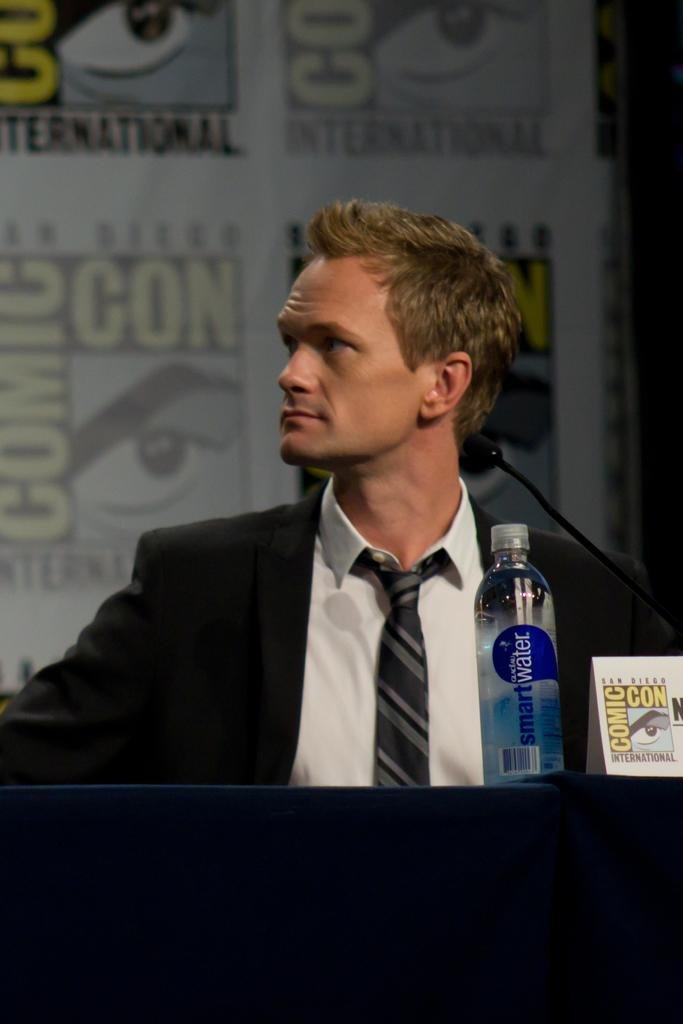What is the main subject in the center of the image? There is a person sitting on a chair in the center of the image. What is in front of the chair? There is a table in front of the chair. What is on the table? There is a cloth, a water bottle, and a paper on the table. What can be seen in the background of the image? There is a wall in the background of the image. What type of liquid is being poured from the jeans in the image? There are no jeans or liquid present in the image. 